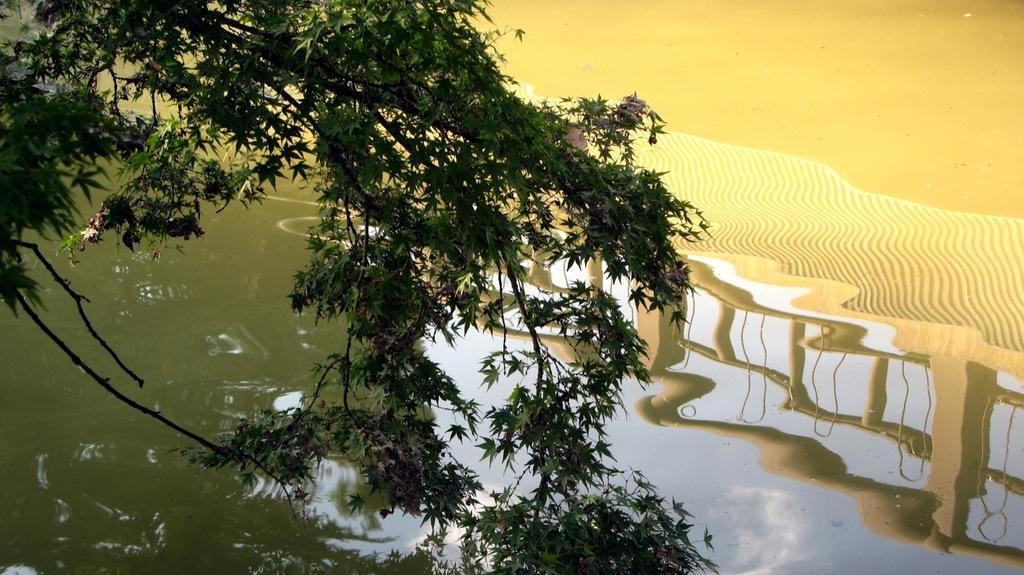In one or two sentences, can you explain what this image depicts? In this picture I can see the leaves on the stems in front and I can see the water and on the reflection I can see the sky, few trees and the railing. 